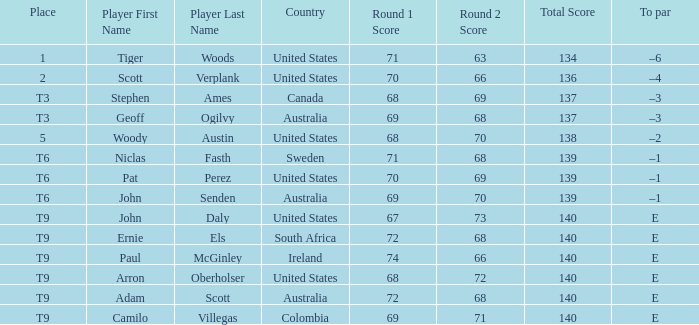What is Canada's score? 68-69=137. 